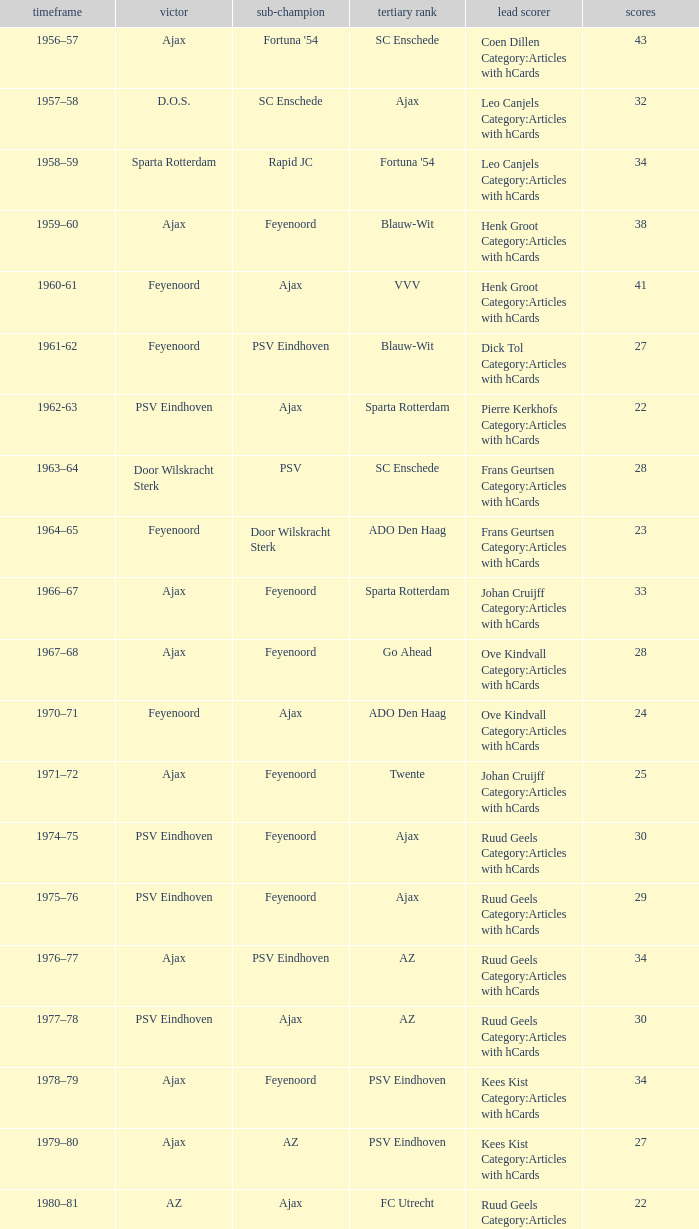When az is the runner up nad feyenoord came in third place how many overall winners are there? 1.0. 